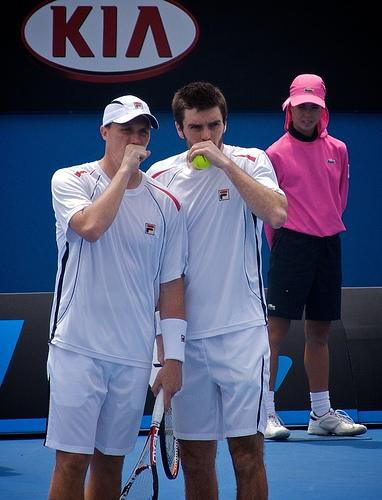Why are they covering their mouths?

Choices:
A) are laughing
B) are eating
C) conceal conversation
D) are coughing conceal conversation 